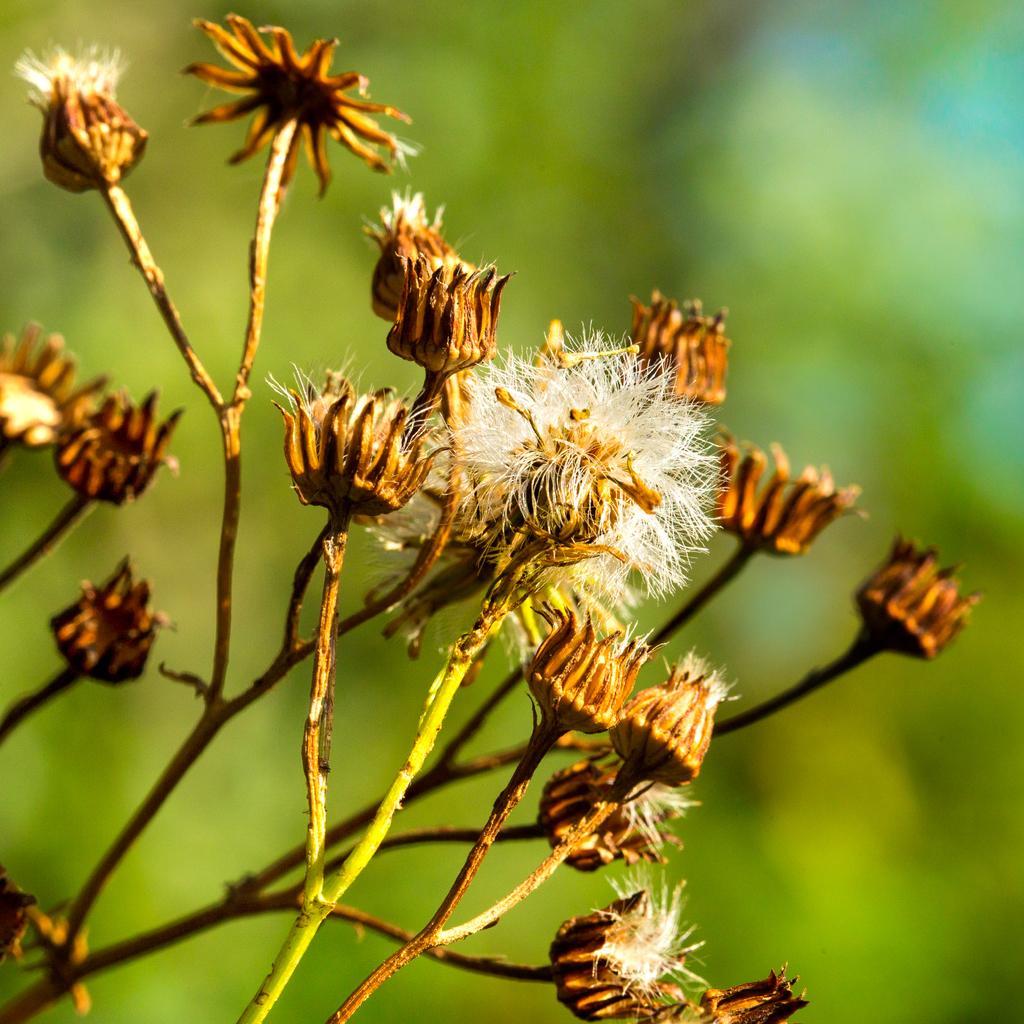Describe this image in one or two sentences. This image is taken outdoors. In this image the background is a little blurred. On the left side of the image there is a plant. 